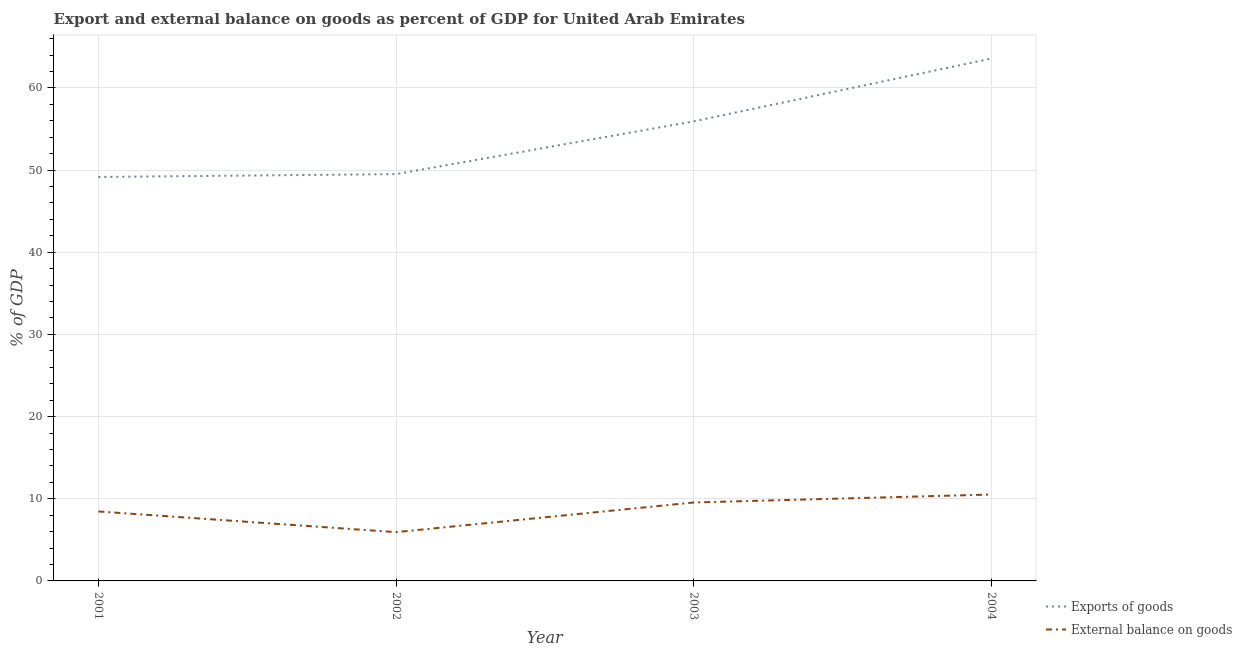How many different coloured lines are there?
Provide a succinct answer. 2. Does the line corresponding to export of goods as percentage of gdp intersect with the line corresponding to external balance on goods as percentage of gdp?
Keep it short and to the point. No. Is the number of lines equal to the number of legend labels?
Offer a terse response. Yes. What is the export of goods as percentage of gdp in 2003?
Keep it short and to the point. 55.92. Across all years, what is the maximum external balance on goods as percentage of gdp?
Your response must be concise. 10.51. Across all years, what is the minimum export of goods as percentage of gdp?
Ensure brevity in your answer.  49.16. In which year was the export of goods as percentage of gdp minimum?
Make the answer very short. 2001. What is the total export of goods as percentage of gdp in the graph?
Your answer should be compact. 218.15. What is the difference between the external balance on goods as percentage of gdp in 2001 and that in 2004?
Your answer should be very brief. -2.06. What is the difference between the export of goods as percentage of gdp in 2002 and the external balance on goods as percentage of gdp in 2001?
Keep it short and to the point. 41.05. What is the average export of goods as percentage of gdp per year?
Provide a short and direct response. 54.54. In the year 2001, what is the difference between the export of goods as percentage of gdp and external balance on goods as percentage of gdp?
Keep it short and to the point. 40.71. In how many years, is the export of goods as percentage of gdp greater than 18 %?
Your answer should be very brief. 4. What is the ratio of the external balance on goods as percentage of gdp in 2002 to that in 2003?
Your answer should be compact. 0.62. What is the difference between the highest and the second highest export of goods as percentage of gdp?
Offer a very short reply. 7.64. What is the difference between the highest and the lowest export of goods as percentage of gdp?
Your answer should be very brief. 14.41. Is the sum of the export of goods as percentage of gdp in 2001 and 2003 greater than the maximum external balance on goods as percentage of gdp across all years?
Provide a succinct answer. Yes. Does the external balance on goods as percentage of gdp monotonically increase over the years?
Provide a short and direct response. No. Is the export of goods as percentage of gdp strictly greater than the external balance on goods as percentage of gdp over the years?
Keep it short and to the point. Yes. Is the external balance on goods as percentage of gdp strictly less than the export of goods as percentage of gdp over the years?
Offer a terse response. Yes. How many lines are there?
Ensure brevity in your answer.  2. How many years are there in the graph?
Keep it short and to the point. 4. Are the values on the major ticks of Y-axis written in scientific E-notation?
Keep it short and to the point. No. Where does the legend appear in the graph?
Give a very brief answer. Bottom right. How are the legend labels stacked?
Keep it short and to the point. Vertical. What is the title of the graph?
Provide a succinct answer. Export and external balance on goods as percent of GDP for United Arab Emirates. Does "Research and Development" appear as one of the legend labels in the graph?
Offer a very short reply. No. What is the label or title of the Y-axis?
Ensure brevity in your answer.  % of GDP. What is the % of GDP of Exports of goods in 2001?
Offer a very short reply. 49.16. What is the % of GDP of External balance on goods in 2001?
Ensure brevity in your answer.  8.45. What is the % of GDP of Exports of goods in 2002?
Give a very brief answer. 49.5. What is the % of GDP in External balance on goods in 2002?
Your response must be concise. 5.94. What is the % of GDP in Exports of goods in 2003?
Give a very brief answer. 55.92. What is the % of GDP of External balance on goods in 2003?
Ensure brevity in your answer.  9.55. What is the % of GDP of Exports of goods in 2004?
Ensure brevity in your answer.  63.57. What is the % of GDP of External balance on goods in 2004?
Give a very brief answer. 10.51. Across all years, what is the maximum % of GDP of Exports of goods?
Keep it short and to the point. 63.57. Across all years, what is the maximum % of GDP of External balance on goods?
Give a very brief answer. 10.51. Across all years, what is the minimum % of GDP of Exports of goods?
Make the answer very short. 49.16. Across all years, what is the minimum % of GDP in External balance on goods?
Your answer should be compact. 5.94. What is the total % of GDP in Exports of goods in the graph?
Your answer should be very brief. 218.15. What is the total % of GDP of External balance on goods in the graph?
Give a very brief answer. 34.45. What is the difference between the % of GDP of Exports of goods in 2001 and that in 2002?
Your response must be concise. -0.34. What is the difference between the % of GDP in External balance on goods in 2001 and that in 2002?
Make the answer very short. 2.52. What is the difference between the % of GDP of Exports of goods in 2001 and that in 2003?
Give a very brief answer. -6.76. What is the difference between the % of GDP of External balance on goods in 2001 and that in 2003?
Keep it short and to the point. -1.09. What is the difference between the % of GDP in Exports of goods in 2001 and that in 2004?
Provide a succinct answer. -14.41. What is the difference between the % of GDP of External balance on goods in 2001 and that in 2004?
Provide a short and direct response. -2.06. What is the difference between the % of GDP in Exports of goods in 2002 and that in 2003?
Your answer should be compact. -6.42. What is the difference between the % of GDP of External balance on goods in 2002 and that in 2003?
Your answer should be very brief. -3.61. What is the difference between the % of GDP of Exports of goods in 2002 and that in 2004?
Provide a short and direct response. -14.06. What is the difference between the % of GDP of External balance on goods in 2002 and that in 2004?
Keep it short and to the point. -4.58. What is the difference between the % of GDP in Exports of goods in 2003 and that in 2004?
Offer a terse response. -7.64. What is the difference between the % of GDP in External balance on goods in 2003 and that in 2004?
Ensure brevity in your answer.  -0.97. What is the difference between the % of GDP in Exports of goods in 2001 and the % of GDP in External balance on goods in 2002?
Your response must be concise. 43.22. What is the difference between the % of GDP of Exports of goods in 2001 and the % of GDP of External balance on goods in 2003?
Make the answer very short. 39.61. What is the difference between the % of GDP in Exports of goods in 2001 and the % of GDP in External balance on goods in 2004?
Ensure brevity in your answer.  38.65. What is the difference between the % of GDP of Exports of goods in 2002 and the % of GDP of External balance on goods in 2003?
Give a very brief answer. 39.96. What is the difference between the % of GDP in Exports of goods in 2002 and the % of GDP in External balance on goods in 2004?
Give a very brief answer. 38.99. What is the difference between the % of GDP of Exports of goods in 2003 and the % of GDP of External balance on goods in 2004?
Your answer should be compact. 45.41. What is the average % of GDP of Exports of goods per year?
Provide a short and direct response. 54.54. What is the average % of GDP of External balance on goods per year?
Offer a terse response. 8.61. In the year 2001, what is the difference between the % of GDP in Exports of goods and % of GDP in External balance on goods?
Provide a short and direct response. 40.71. In the year 2002, what is the difference between the % of GDP in Exports of goods and % of GDP in External balance on goods?
Your answer should be very brief. 43.57. In the year 2003, what is the difference between the % of GDP in Exports of goods and % of GDP in External balance on goods?
Ensure brevity in your answer.  46.38. In the year 2004, what is the difference between the % of GDP in Exports of goods and % of GDP in External balance on goods?
Your response must be concise. 53.05. What is the ratio of the % of GDP in External balance on goods in 2001 to that in 2002?
Provide a succinct answer. 1.42. What is the ratio of the % of GDP of Exports of goods in 2001 to that in 2003?
Keep it short and to the point. 0.88. What is the ratio of the % of GDP in External balance on goods in 2001 to that in 2003?
Provide a succinct answer. 0.89. What is the ratio of the % of GDP in Exports of goods in 2001 to that in 2004?
Your answer should be very brief. 0.77. What is the ratio of the % of GDP in External balance on goods in 2001 to that in 2004?
Provide a short and direct response. 0.8. What is the ratio of the % of GDP of Exports of goods in 2002 to that in 2003?
Ensure brevity in your answer.  0.89. What is the ratio of the % of GDP of External balance on goods in 2002 to that in 2003?
Your response must be concise. 0.62. What is the ratio of the % of GDP of Exports of goods in 2002 to that in 2004?
Make the answer very short. 0.78. What is the ratio of the % of GDP in External balance on goods in 2002 to that in 2004?
Make the answer very short. 0.56. What is the ratio of the % of GDP of Exports of goods in 2003 to that in 2004?
Offer a terse response. 0.88. What is the ratio of the % of GDP in External balance on goods in 2003 to that in 2004?
Offer a very short reply. 0.91. What is the difference between the highest and the second highest % of GDP of Exports of goods?
Your answer should be very brief. 7.64. What is the difference between the highest and the second highest % of GDP in External balance on goods?
Offer a terse response. 0.97. What is the difference between the highest and the lowest % of GDP of Exports of goods?
Give a very brief answer. 14.41. What is the difference between the highest and the lowest % of GDP in External balance on goods?
Provide a short and direct response. 4.58. 